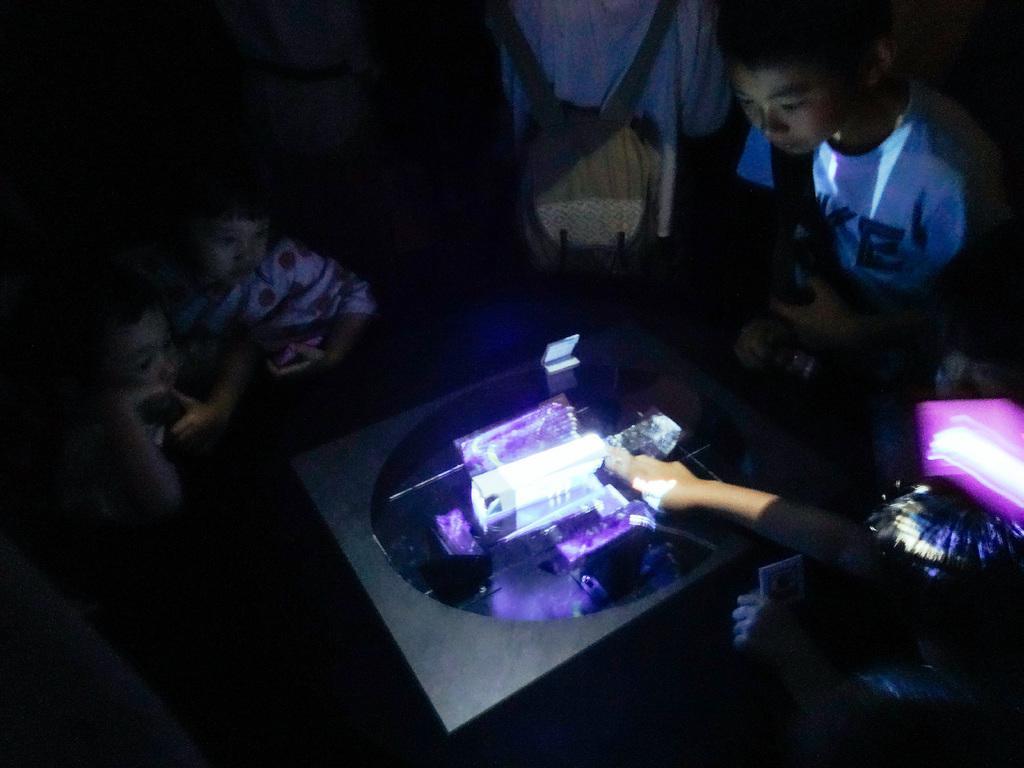Please provide a concise description of this image. In this image we can see few children. We can see a person with a bag. There is a table. On the table there is light. On the right side we can see a person holding something in the hand. 